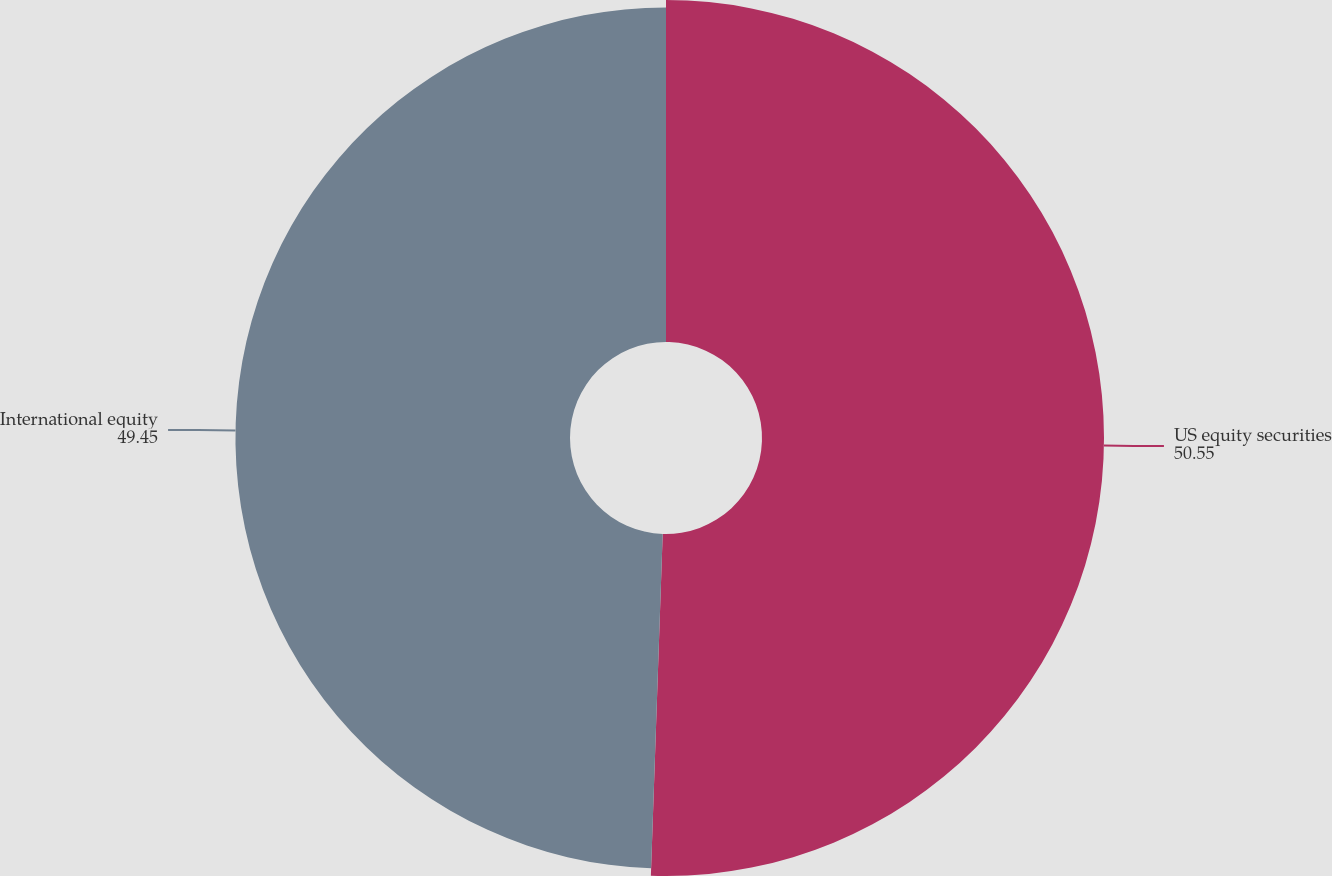Convert chart. <chart><loc_0><loc_0><loc_500><loc_500><pie_chart><fcel>US equity securities<fcel>International equity<nl><fcel>50.55%<fcel>49.45%<nl></chart> 